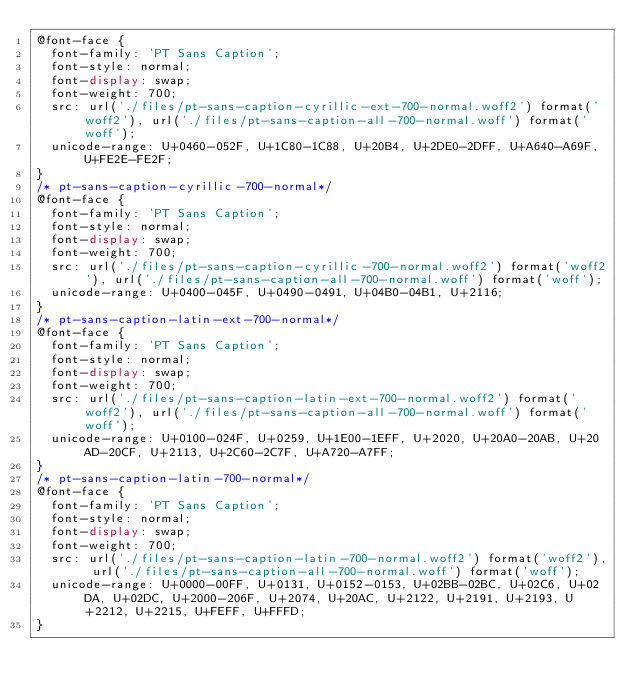<code> <loc_0><loc_0><loc_500><loc_500><_CSS_>@font-face {
  font-family: 'PT Sans Caption';
  font-style: normal;
  font-display: swap;
  font-weight: 700;
  src: url('./files/pt-sans-caption-cyrillic-ext-700-normal.woff2') format('woff2'), url('./files/pt-sans-caption-all-700-normal.woff') format('woff');
  unicode-range: U+0460-052F, U+1C80-1C88, U+20B4, U+2DE0-2DFF, U+A640-A69F, U+FE2E-FE2F;
}
/* pt-sans-caption-cyrillic-700-normal*/
@font-face {
  font-family: 'PT Sans Caption';
  font-style: normal;
  font-display: swap;
  font-weight: 700;
  src: url('./files/pt-sans-caption-cyrillic-700-normal.woff2') format('woff2'), url('./files/pt-sans-caption-all-700-normal.woff') format('woff');
  unicode-range: U+0400-045F, U+0490-0491, U+04B0-04B1, U+2116;
}
/* pt-sans-caption-latin-ext-700-normal*/
@font-face {
  font-family: 'PT Sans Caption';
  font-style: normal;
  font-display: swap;
  font-weight: 700;
  src: url('./files/pt-sans-caption-latin-ext-700-normal.woff2') format('woff2'), url('./files/pt-sans-caption-all-700-normal.woff') format('woff');
  unicode-range: U+0100-024F, U+0259, U+1E00-1EFF, U+2020, U+20A0-20AB, U+20AD-20CF, U+2113, U+2C60-2C7F, U+A720-A7FF;
}
/* pt-sans-caption-latin-700-normal*/
@font-face {
  font-family: 'PT Sans Caption';
  font-style: normal;
  font-display: swap;
  font-weight: 700;
  src: url('./files/pt-sans-caption-latin-700-normal.woff2') format('woff2'), url('./files/pt-sans-caption-all-700-normal.woff') format('woff');
  unicode-range: U+0000-00FF, U+0131, U+0152-0153, U+02BB-02BC, U+02C6, U+02DA, U+02DC, U+2000-206F, U+2074, U+20AC, U+2122, U+2191, U+2193, U+2212, U+2215, U+FEFF, U+FFFD;
}
</code> 